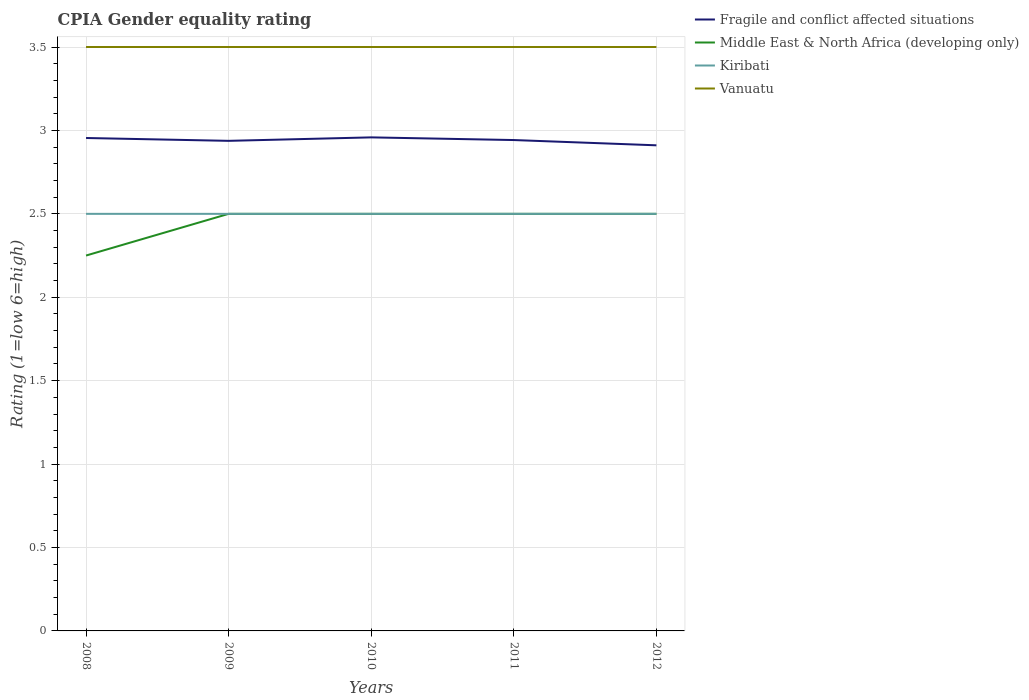How many different coloured lines are there?
Offer a very short reply. 4. Across all years, what is the maximum CPIA rating in Middle East & North Africa (developing only)?
Make the answer very short. 2.25. What is the total CPIA rating in Kiribati in the graph?
Provide a short and direct response. 0. What is the difference between the highest and the second highest CPIA rating in Middle East & North Africa (developing only)?
Provide a succinct answer. 0.25. How many years are there in the graph?
Ensure brevity in your answer.  5. What is the difference between two consecutive major ticks on the Y-axis?
Give a very brief answer. 0.5. Are the values on the major ticks of Y-axis written in scientific E-notation?
Offer a terse response. No. Where does the legend appear in the graph?
Your answer should be very brief. Top right. What is the title of the graph?
Provide a succinct answer. CPIA Gender equality rating. What is the label or title of the Y-axis?
Offer a very short reply. Rating (1=low 6=high). What is the Rating (1=low 6=high) in Fragile and conflict affected situations in 2008?
Ensure brevity in your answer.  2.95. What is the Rating (1=low 6=high) in Middle East & North Africa (developing only) in 2008?
Keep it short and to the point. 2.25. What is the Rating (1=low 6=high) in Kiribati in 2008?
Provide a short and direct response. 2.5. What is the Rating (1=low 6=high) in Vanuatu in 2008?
Your answer should be compact. 3.5. What is the Rating (1=low 6=high) in Fragile and conflict affected situations in 2009?
Provide a short and direct response. 2.94. What is the Rating (1=low 6=high) in Kiribati in 2009?
Give a very brief answer. 2.5. What is the Rating (1=low 6=high) of Vanuatu in 2009?
Ensure brevity in your answer.  3.5. What is the Rating (1=low 6=high) in Fragile and conflict affected situations in 2010?
Provide a succinct answer. 2.96. What is the Rating (1=low 6=high) of Middle East & North Africa (developing only) in 2010?
Provide a short and direct response. 2.5. What is the Rating (1=low 6=high) in Kiribati in 2010?
Your answer should be compact. 2.5. What is the Rating (1=low 6=high) in Vanuatu in 2010?
Provide a short and direct response. 3.5. What is the Rating (1=low 6=high) in Fragile and conflict affected situations in 2011?
Provide a succinct answer. 2.94. What is the Rating (1=low 6=high) of Middle East & North Africa (developing only) in 2011?
Provide a succinct answer. 2.5. What is the Rating (1=low 6=high) of Vanuatu in 2011?
Your response must be concise. 3.5. What is the Rating (1=low 6=high) of Fragile and conflict affected situations in 2012?
Your response must be concise. 2.91. What is the Rating (1=low 6=high) of Middle East & North Africa (developing only) in 2012?
Provide a succinct answer. 2.5. Across all years, what is the maximum Rating (1=low 6=high) of Fragile and conflict affected situations?
Your response must be concise. 2.96. Across all years, what is the maximum Rating (1=low 6=high) of Kiribati?
Your response must be concise. 2.5. Across all years, what is the maximum Rating (1=low 6=high) in Vanuatu?
Your answer should be very brief. 3.5. Across all years, what is the minimum Rating (1=low 6=high) in Fragile and conflict affected situations?
Your answer should be very brief. 2.91. Across all years, what is the minimum Rating (1=low 6=high) of Middle East & North Africa (developing only)?
Ensure brevity in your answer.  2.25. What is the total Rating (1=low 6=high) in Fragile and conflict affected situations in the graph?
Provide a short and direct response. 14.7. What is the total Rating (1=low 6=high) in Middle East & North Africa (developing only) in the graph?
Your response must be concise. 12.25. What is the total Rating (1=low 6=high) in Kiribati in the graph?
Offer a terse response. 12.5. What is the difference between the Rating (1=low 6=high) in Fragile and conflict affected situations in 2008 and that in 2009?
Offer a terse response. 0.02. What is the difference between the Rating (1=low 6=high) in Middle East & North Africa (developing only) in 2008 and that in 2009?
Keep it short and to the point. -0.25. What is the difference between the Rating (1=low 6=high) of Kiribati in 2008 and that in 2009?
Your answer should be compact. 0. What is the difference between the Rating (1=low 6=high) of Vanuatu in 2008 and that in 2009?
Keep it short and to the point. 0. What is the difference between the Rating (1=low 6=high) in Fragile and conflict affected situations in 2008 and that in 2010?
Provide a succinct answer. -0. What is the difference between the Rating (1=low 6=high) in Kiribati in 2008 and that in 2010?
Provide a short and direct response. 0. What is the difference between the Rating (1=low 6=high) of Fragile and conflict affected situations in 2008 and that in 2011?
Make the answer very short. 0.01. What is the difference between the Rating (1=low 6=high) in Kiribati in 2008 and that in 2011?
Provide a short and direct response. 0. What is the difference between the Rating (1=low 6=high) of Vanuatu in 2008 and that in 2011?
Your response must be concise. 0. What is the difference between the Rating (1=low 6=high) of Fragile and conflict affected situations in 2008 and that in 2012?
Make the answer very short. 0.04. What is the difference between the Rating (1=low 6=high) in Vanuatu in 2008 and that in 2012?
Provide a short and direct response. 0. What is the difference between the Rating (1=low 6=high) of Fragile and conflict affected situations in 2009 and that in 2010?
Offer a terse response. -0.02. What is the difference between the Rating (1=low 6=high) of Middle East & North Africa (developing only) in 2009 and that in 2010?
Provide a short and direct response. 0. What is the difference between the Rating (1=low 6=high) of Kiribati in 2009 and that in 2010?
Your response must be concise. 0. What is the difference between the Rating (1=low 6=high) in Vanuatu in 2009 and that in 2010?
Your answer should be compact. 0. What is the difference between the Rating (1=low 6=high) in Fragile and conflict affected situations in 2009 and that in 2011?
Provide a short and direct response. -0. What is the difference between the Rating (1=low 6=high) of Middle East & North Africa (developing only) in 2009 and that in 2011?
Give a very brief answer. 0. What is the difference between the Rating (1=low 6=high) in Vanuatu in 2009 and that in 2011?
Make the answer very short. 0. What is the difference between the Rating (1=low 6=high) in Fragile and conflict affected situations in 2009 and that in 2012?
Ensure brevity in your answer.  0.03. What is the difference between the Rating (1=low 6=high) of Middle East & North Africa (developing only) in 2009 and that in 2012?
Your answer should be compact. 0. What is the difference between the Rating (1=low 6=high) in Kiribati in 2009 and that in 2012?
Give a very brief answer. 0. What is the difference between the Rating (1=low 6=high) in Vanuatu in 2009 and that in 2012?
Offer a terse response. 0. What is the difference between the Rating (1=low 6=high) in Fragile and conflict affected situations in 2010 and that in 2011?
Offer a terse response. 0.02. What is the difference between the Rating (1=low 6=high) of Kiribati in 2010 and that in 2011?
Your answer should be very brief. 0. What is the difference between the Rating (1=low 6=high) in Fragile and conflict affected situations in 2010 and that in 2012?
Give a very brief answer. 0.05. What is the difference between the Rating (1=low 6=high) in Fragile and conflict affected situations in 2011 and that in 2012?
Offer a terse response. 0.03. What is the difference between the Rating (1=low 6=high) of Middle East & North Africa (developing only) in 2011 and that in 2012?
Make the answer very short. 0. What is the difference between the Rating (1=low 6=high) of Fragile and conflict affected situations in 2008 and the Rating (1=low 6=high) of Middle East & North Africa (developing only) in 2009?
Keep it short and to the point. 0.45. What is the difference between the Rating (1=low 6=high) of Fragile and conflict affected situations in 2008 and the Rating (1=low 6=high) of Kiribati in 2009?
Your answer should be very brief. 0.45. What is the difference between the Rating (1=low 6=high) of Fragile and conflict affected situations in 2008 and the Rating (1=low 6=high) of Vanuatu in 2009?
Give a very brief answer. -0.55. What is the difference between the Rating (1=low 6=high) in Middle East & North Africa (developing only) in 2008 and the Rating (1=low 6=high) in Kiribati in 2009?
Provide a short and direct response. -0.25. What is the difference between the Rating (1=low 6=high) of Middle East & North Africa (developing only) in 2008 and the Rating (1=low 6=high) of Vanuatu in 2009?
Keep it short and to the point. -1.25. What is the difference between the Rating (1=low 6=high) of Fragile and conflict affected situations in 2008 and the Rating (1=low 6=high) of Middle East & North Africa (developing only) in 2010?
Your answer should be compact. 0.45. What is the difference between the Rating (1=low 6=high) of Fragile and conflict affected situations in 2008 and the Rating (1=low 6=high) of Kiribati in 2010?
Your response must be concise. 0.45. What is the difference between the Rating (1=low 6=high) in Fragile and conflict affected situations in 2008 and the Rating (1=low 6=high) in Vanuatu in 2010?
Give a very brief answer. -0.55. What is the difference between the Rating (1=low 6=high) of Middle East & North Africa (developing only) in 2008 and the Rating (1=low 6=high) of Vanuatu in 2010?
Provide a succinct answer. -1.25. What is the difference between the Rating (1=low 6=high) of Fragile and conflict affected situations in 2008 and the Rating (1=low 6=high) of Middle East & North Africa (developing only) in 2011?
Provide a succinct answer. 0.45. What is the difference between the Rating (1=low 6=high) of Fragile and conflict affected situations in 2008 and the Rating (1=low 6=high) of Kiribati in 2011?
Your response must be concise. 0.45. What is the difference between the Rating (1=low 6=high) in Fragile and conflict affected situations in 2008 and the Rating (1=low 6=high) in Vanuatu in 2011?
Offer a very short reply. -0.55. What is the difference between the Rating (1=low 6=high) in Middle East & North Africa (developing only) in 2008 and the Rating (1=low 6=high) in Vanuatu in 2011?
Keep it short and to the point. -1.25. What is the difference between the Rating (1=low 6=high) in Fragile and conflict affected situations in 2008 and the Rating (1=low 6=high) in Middle East & North Africa (developing only) in 2012?
Your answer should be very brief. 0.45. What is the difference between the Rating (1=low 6=high) of Fragile and conflict affected situations in 2008 and the Rating (1=low 6=high) of Kiribati in 2012?
Your answer should be very brief. 0.45. What is the difference between the Rating (1=low 6=high) of Fragile and conflict affected situations in 2008 and the Rating (1=low 6=high) of Vanuatu in 2012?
Offer a very short reply. -0.55. What is the difference between the Rating (1=low 6=high) of Middle East & North Africa (developing only) in 2008 and the Rating (1=low 6=high) of Kiribati in 2012?
Provide a short and direct response. -0.25. What is the difference between the Rating (1=low 6=high) in Middle East & North Africa (developing only) in 2008 and the Rating (1=low 6=high) in Vanuatu in 2012?
Keep it short and to the point. -1.25. What is the difference between the Rating (1=low 6=high) of Fragile and conflict affected situations in 2009 and the Rating (1=low 6=high) of Middle East & North Africa (developing only) in 2010?
Provide a short and direct response. 0.44. What is the difference between the Rating (1=low 6=high) in Fragile and conflict affected situations in 2009 and the Rating (1=low 6=high) in Kiribati in 2010?
Offer a terse response. 0.44. What is the difference between the Rating (1=low 6=high) in Fragile and conflict affected situations in 2009 and the Rating (1=low 6=high) in Vanuatu in 2010?
Provide a succinct answer. -0.56. What is the difference between the Rating (1=low 6=high) in Middle East & North Africa (developing only) in 2009 and the Rating (1=low 6=high) in Kiribati in 2010?
Give a very brief answer. 0. What is the difference between the Rating (1=low 6=high) in Fragile and conflict affected situations in 2009 and the Rating (1=low 6=high) in Middle East & North Africa (developing only) in 2011?
Your response must be concise. 0.44. What is the difference between the Rating (1=low 6=high) of Fragile and conflict affected situations in 2009 and the Rating (1=low 6=high) of Kiribati in 2011?
Make the answer very short. 0.44. What is the difference between the Rating (1=low 6=high) of Fragile and conflict affected situations in 2009 and the Rating (1=low 6=high) of Vanuatu in 2011?
Your answer should be very brief. -0.56. What is the difference between the Rating (1=low 6=high) in Middle East & North Africa (developing only) in 2009 and the Rating (1=low 6=high) in Kiribati in 2011?
Keep it short and to the point. 0. What is the difference between the Rating (1=low 6=high) of Fragile and conflict affected situations in 2009 and the Rating (1=low 6=high) of Middle East & North Africa (developing only) in 2012?
Offer a terse response. 0.44. What is the difference between the Rating (1=low 6=high) in Fragile and conflict affected situations in 2009 and the Rating (1=low 6=high) in Kiribati in 2012?
Offer a very short reply. 0.44. What is the difference between the Rating (1=low 6=high) of Fragile and conflict affected situations in 2009 and the Rating (1=low 6=high) of Vanuatu in 2012?
Offer a terse response. -0.56. What is the difference between the Rating (1=low 6=high) in Middle East & North Africa (developing only) in 2009 and the Rating (1=low 6=high) in Kiribati in 2012?
Your answer should be compact. 0. What is the difference between the Rating (1=low 6=high) of Middle East & North Africa (developing only) in 2009 and the Rating (1=low 6=high) of Vanuatu in 2012?
Keep it short and to the point. -1. What is the difference between the Rating (1=low 6=high) in Kiribati in 2009 and the Rating (1=low 6=high) in Vanuatu in 2012?
Your answer should be compact. -1. What is the difference between the Rating (1=low 6=high) in Fragile and conflict affected situations in 2010 and the Rating (1=low 6=high) in Middle East & North Africa (developing only) in 2011?
Keep it short and to the point. 0.46. What is the difference between the Rating (1=low 6=high) in Fragile and conflict affected situations in 2010 and the Rating (1=low 6=high) in Kiribati in 2011?
Provide a short and direct response. 0.46. What is the difference between the Rating (1=low 6=high) of Fragile and conflict affected situations in 2010 and the Rating (1=low 6=high) of Vanuatu in 2011?
Your answer should be compact. -0.54. What is the difference between the Rating (1=low 6=high) of Middle East & North Africa (developing only) in 2010 and the Rating (1=low 6=high) of Kiribati in 2011?
Provide a short and direct response. 0. What is the difference between the Rating (1=low 6=high) of Fragile and conflict affected situations in 2010 and the Rating (1=low 6=high) of Middle East & North Africa (developing only) in 2012?
Your answer should be compact. 0.46. What is the difference between the Rating (1=low 6=high) of Fragile and conflict affected situations in 2010 and the Rating (1=low 6=high) of Kiribati in 2012?
Provide a succinct answer. 0.46. What is the difference between the Rating (1=low 6=high) in Fragile and conflict affected situations in 2010 and the Rating (1=low 6=high) in Vanuatu in 2012?
Your answer should be very brief. -0.54. What is the difference between the Rating (1=low 6=high) of Middle East & North Africa (developing only) in 2010 and the Rating (1=low 6=high) of Kiribati in 2012?
Ensure brevity in your answer.  0. What is the difference between the Rating (1=low 6=high) of Fragile and conflict affected situations in 2011 and the Rating (1=low 6=high) of Middle East & North Africa (developing only) in 2012?
Make the answer very short. 0.44. What is the difference between the Rating (1=low 6=high) of Fragile and conflict affected situations in 2011 and the Rating (1=low 6=high) of Kiribati in 2012?
Your answer should be very brief. 0.44. What is the difference between the Rating (1=low 6=high) of Fragile and conflict affected situations in 2011 and the Rating (1=low 6=high) of Vanuatu in 2012?
Provide a succinct answer. -0.56. What is the difference between the Rating (1=low 6=high) of Kiribati in 2011 and the Rating (1=low 6=high) of Vanuatu in 2012?
Offer a terse response. -1. What is the average Rating (1=low 6=high) of Fragile and conflict affected situations per year?
Offer a very short reply. 2.94. What is the average Rating (1=low 6=high) of Middle East & North Africa (developing only) per year?
Keep it short and to the point. 2.45. What is the average Rating (1=low 6=high) in Kiribati per year?
Ensure brevity in your answer.  2.5. In the year 2008, what is the difference between the Rating (1=low 6=high) of Fragile and conflict affected situations and Rating (1=low 6=high) of Middle East & North Africa (developing only)?
Provide a short and direct response. 0.7. In the year 2008, what is the difference between the Rating (1=low 6=high) in Fragile and conflict affected situations and Rating (1=low 6=high) in Kiribati?
Offer a very short reply. 0.45. In the year 2008, what is the difference between the Rating (1=low 6=high) in Fragile and conflict affected situations and Rating (1=low 6=high) in Vanuatu?
Your answer should be very brief. -0.55. In the year 2008, what is the difference between the Rating (1=low 6=high) in Middle East & North Africa (developing only) and Rating (1=low 6=high) in Vanuatu?
Ensure brevity in your answer.  -1.25. In the year 2008, what is the difference between the Rating (1=low 6=high) in Kiribati and Rating (1=low 6=high) in Vanuatu?
Your response must be concise. -1. In the year 2009, what is the difference between the Rating (1=low 6=high) in Fragile and conflict affected situations and Rating (1=low 6=high) in Middle East & North Africa (developing only)?
Your answer should be compact. 0.44. In the year 2009, what is the difference between the Rating (1=low 6=high) in Fragile and conflict affected situations and Rating (1=low 6=high) in Kiribati?
Ensure brevity in your answer.  0.44. In the year 2009, what is the difference between the Rating (1=low 6=high) of Fragile and conflict affected situations and Rating (1=low 6=high) of Vanuatu?
Your answer should be compact. -0.56. In the year 2009, what is the difference between the Rating (1=low 6=high) of Middle East & North Africa (developing only) and Rating (1=low 6=high) of Kiribati?
Keep it short and to the point. 0. In the year 2010, what is the difference between the Rating (1=low 6=high) of Fragile and conflict affected situations and Rating (1=low 6=high) of Middle East & North Africa (developing only)?
Provide a short and direct response. 0.46. In the year 2010, what is the difference between the Rating (1=low 6=high) in Fragile and conflict affected situations and Rating (1=low 6=high) in Kiribati?
Keep it short and to the point. 0.46. In the year 2010, what is the difference between the Rating (1=low 6=high) of Fragile and conflict affected situations and Rating (1=low 6=high) of Vanuatu?
Make the answer very short. -0.54. In the year 2010, what is the difference between the Rating (1=low 6=high) in Middle East & North Africa (developing only) and Rating (1=low 6=high) in Vanuatu?
Your response must be concise. -1. In the year 2011, what is the difference between the Rating (1=low 6=high) of Fragile and conflict affected situations and Rating (1=low 6=high) of Middle East & North Africa (developing only)?
Make the answer very short. 0.44. In the year 2011, what is the difference between the Rating (1=low 6=high) in Fragile and conflict affected situations and Rating (1=low 6=high) in Kiribati?
Give a very brief answer. 0.44. In the year 2011, what is the difference between the Rating (1=low 6=high) in Fragile and conflict affected situations and Rating (1=low 6=high) in Vanuatu?
Keep it short and to the point. -0.56. In the year 2011, what is the difference between the Rating (1=low 6=high) in Middle East & North Africa (developing only) and Rating (1=low 6=high) in Kiribati?
Provide a short and direct response. 0. In the year 2012, what is the difference between the Rating (1=low 6=high) in Fragile and conflict affected situations and Rating (1=low 6=high) in Middle East & North Africa (developing only)?
Offer a very short reply. 0.41. In the year 2012, what is the difference between the Rating (1=low 6=high) of Fragile and conflict affected situations and Rating (1=low 6=high) of Kiribati?
Provide a succinct answer. 0.41. In the year 2012, what is the difference between the Rating (1=low 6=high) in Fragile and conflict affected situations and Rating (1=low 6=high) in Vanuatu?
Offer a terse response. -0.59. In the year 2012, what is the difference between the Rating (1=low 6=high) of Middle East & North Africa (developing only) and Rating (1=low 6=high) of Kiribati?
Provide a short and direct response. 0. In the year 2012, what is the difference between the Rating (1=low 6=high) in Middle East & North Africa (developing only) and Rating (1=low 6=high) in Vanuatu?
Ensure brevity in your answer.  -1. In the year 2012, what is the difference between the Rating (1=low 6=high) of Kiribati and Rating (1=low 6=high) of Vanuatu?
Provide a succinct answer. -1. What is the ratio of the Rating (1=low 6=high) of Fragile and conflict affected situations in 2008 to that in 2009?
Make the answer very short. 1.01. What is the ratio of the Rating (1=low 6=high) in Middle East & North Africa (developing only) in 2008 to that in 2009?
Ensure brevity in your answer.  0.9. What is the ratio of the Rating (1=low 6=high) of Kiribati in 2008 to that in 2009?
Provide a succinct answer. 1. What is the ratio of the Rating (1=low 6=high) in Vanuatu in 2008 to that in 2009?
Give a very brief answer. 1. What is the ratio of the Rating (1=low 6=high) of Fragile and conflict affected situations in 2008 to that in 2010?
Keep it short and to the point. 1. What is the ratio of the Rating (1=low 6=high) in Kiribati in 2008 to that in 2010?
Offer a very short reply. 1. What is the ratio of the Rating (1=low 6=high) in Fragile and conflict affected situations in 2008 to that in 2011?
Offer a very short reply. 1. What is the ratio of the Rating (1=low 6=high) of Middle East & North Africa (developing only) in 2008 to that in 2011?
Ensure brevity in your answer.  0.9. What is the ratio of the Rating (1=low 6=high) of Vanuatu in 2008 to that in 2011?
Ensure brevity in your answer.  1. What is the ratio of the Rating (1=low 6=high) in Fragile and conflict affected situations in 2008 to that in 2012?
Provide a succinct answer. 1.02. What is the ratio of the Rating (1=low 6=high) in Middle East & North Africa (developing only) in 2008 to that in 2012?
Your response must be concise. 0.9. What is the ratio of the Rating (1=low 6=high) of Kiribati in 2008 to that in 2012?
Give a very brief answer. 1. What is the ratio of the Rating (1=low 6=high) of Vanuatu in 2008 to that in 2012?
Offer a very short reply. 1. What is the ratio of the Rating (1=low 6=high) in Fragile and conflict affected situations in 2009 to that in 2010?
Your answer should be very brief. 0.99. What is the ratio of the Rating (1=low 6=high) of Middle East & North Africa (developing only) in 2009 to that in 2010?
Provide a succinct answer. 1. What is the ratio of the Rating (1=low 6=high) in Vanuatu in 2009 to that in 2010?
Provide a short and direct response. 1. What is the ratio of the Rating (1=low 6=high) in Fragile and conflict affected situations in 2009 to that in 2011?
Your answer should be compact. 1. What is the ratio of the Rating (1=low 6=high) of Kiribati in 2009 to that in 2011?
Your answer should be very brief. 1. What is the ratio of the Rating (1=low 6=high) in Fragile and conflict affected situations in 2009 to that in 2012?
Make the answer very short. 1.01. What is the ratio of the Rating (1=low 6=high) in Fragile and conflict affected situations in 2010 to that in 2011?
Provide a succinct answer. 1.01. What is the ratio of the Rating (1=low 6=high) in Middle East & North Africa (developing only) in 2010 to that in 2011?
Offer a very short reply. 1. What is the ratio of the Rating (1=low 6=high) of Kiribati in 2010 to that in 2011?
Offer a terse response. 1. What is the ratio of the Rating (1=low 6=high) in Vanuatu in 2010 to that in 2011?
Your answer should be very brief. 1. What is the ratio of the Rating (1=low 6=high) in Fragile and conflict affected situations in 2010 to that in 2012?
Ensure brevity in your answer.  1.02. What is the ratio of the Rating (1=low 6=high) in Middle East & North Africa (developing only) in 2010 to that in 2012?
Give a very brief answer. 1. What is the ratio of the Rating (1=low 6=high) of Kiribati in 2010 to that in 2012?
Keep it short and to the point. 1. What is the ratio of the Rating (1=low 6=high) in Fragile and conflict affected situations in 2011 to that in 2012?
Offer a very short reply. 1.01. What is the ratio of the Rating (1=low 6=high) of Kiribati in 2011 to that in 2012?
Your answer should be compact. 1. What is the ratio of the Rating (1=low 6=high) in Vanuatu in 2011 to that in 2012?
Give a very brief answer. 1. What is the difference between the highest and the second highest Rating (1=low 6=high) of Fragile and conflict affected situations?
Keep it short and to the point. 0. What is the difference between the highest and the second highest Rating (1=low 6=high) of Middle East & North Africa (developing only)?
Your answer should be very brief. 0. What is the difference between the highest and the lowest Rating (1=low 6=high) in Fragile and conflict affected situations?
Ensure brevity in your answer.  0.05. What is the difference between the highest and the lowest Rating (1=low 6=high) in Vanuatu?
Offer a very short reply. 0. 